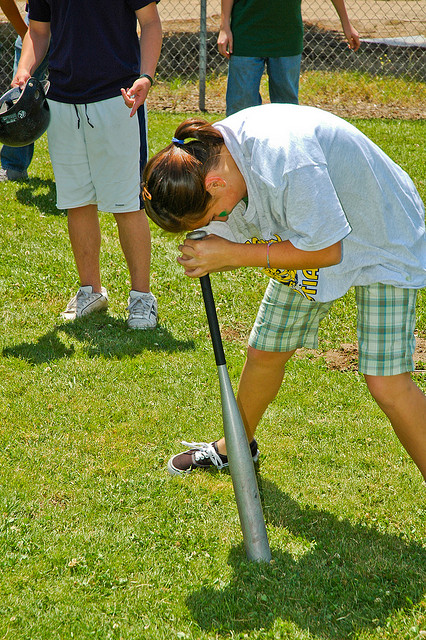Read and extract the text from this image. TIA 